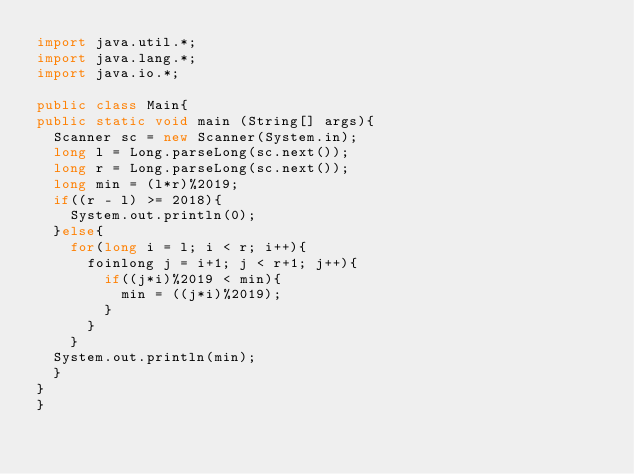<code> <loc_0><loc_0><loc_500><loc_500><_Java_>import java.util.*;
import java.lang.*;
import java.io.*;

public class Main{
public static void main (String[] args){
	Scanner sc = new Scanner(System.in);
	long l = Long.parseLong(sc.next());
	long r = Long.parseLong(sc.next());
	long min = (l*r)%2019;
	if((r - l) >= 2018){
		System.out.println(0);
	}else{
		for(long i = l; i < r; i++){
			foinlong j = i+1; j < r+1; j++){
				if((j*i)%2019 < min){
					min = ((j*i)%2019);
				}
			}
		}
	System.out.println(min);
	}
}
}
</code> 